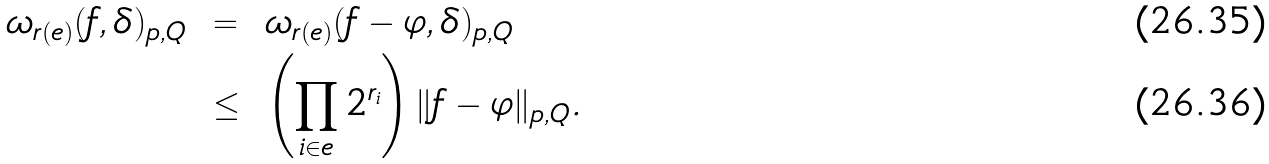Convert formula to latex. <formula><loc_0><loc_0><loc_500><loc_500>\omega _ { r ( e ) } ( f , \delta ) _ { p , Q } \ & = \ \omega _ { r ( e ) } ( f - \varphi , \delta ) _ { p , Q } \\ \ & \leq \ \left ( \prod _ { i \in e } 2 ^ { r _ { i } } \right ) \| f - \varphi \| _ { p , Q } .</formula> 